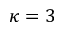Convert formula to latex. <formula><loc_0><loc_0><loc_500><loc_500>\kappa = 3</formula> 